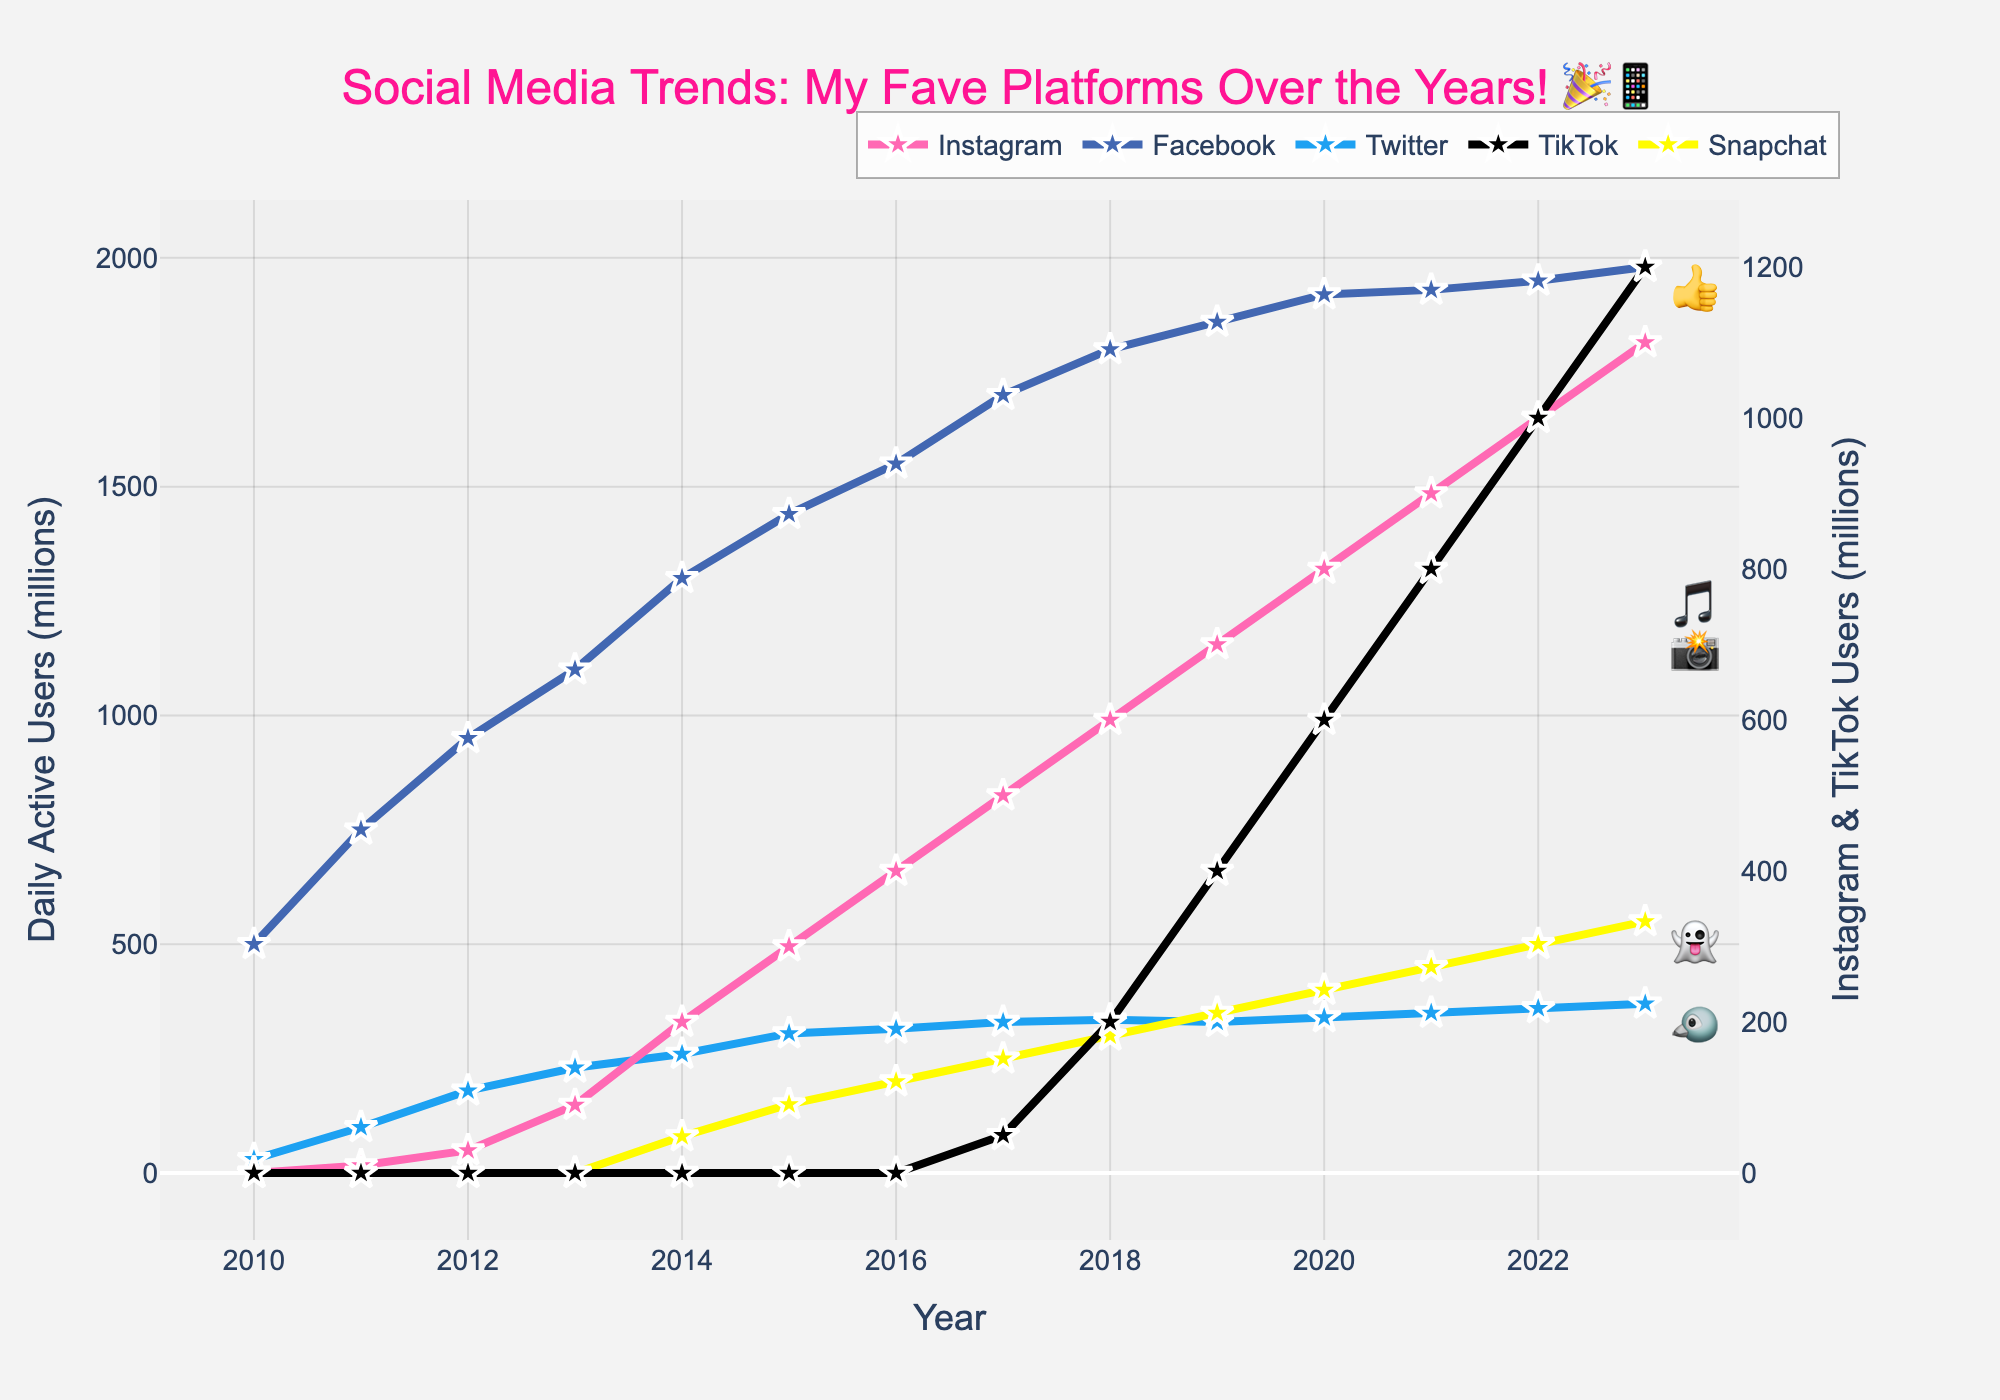What's the trend of daily active users (DAUs) on Facebook from 2010 to 2023? Looking at the line for Facebook, it starts at 500 million DAUs in 2010 and consistently rises each year, reaching 1980 million DAUs by 2023.
Answer: Steadily increasing Which platform had the highest number of DAUs in 2023? By observing the endpoints of each line in 2023, Facebook is at the highest level with 1980 million DAUs.
Answer: Facebook In which year did Instagram surpass 500 million DAUs? By identifying the point where Instagram's line crosses the 500 million DAUs mark, it happens in the year 2017.
Answer: 2017 Compare the growth of TikTok and Twitter from 2018 to 2023. Which one grew more? TikTok grew from 200 million to 1200 million (an increase of 1000 million), while Twitter grew from 335 million to 370 million (an increase of 35 million).
Answer: TikTok grew more What year did TikTok hit 800 million DAUs? By locating the data point on TikTok's line at 800 million DAUs, it occurs in 2021.
Answer: 2021 Which platform had the second-highest growth rate between 2010 and 2023? First, calculate the growth for each platform. Instagram (0 to 1100 million), Facebook (500 to 1980 million), Twitter (30 to 370 million), TikTok (0 to 1200 million), and Snapchat (0 to 550 million). Although TikTok had the highest growth, Instagram has the second-highest growth (by 1100 million).
Answer: Instagram What is the total number of DAUs for all platforms combined in 2020? Sum the number of DAUs for each platform in 2020: Instagram (800) + Facebook (1920) + Twitter (340) + TikTok (600) + Snapchat (400). Total: 800 + 1920 + 340 + 600 + 400 = 4060 million DAUs.
Answer: 4060 million Which platforms have a noticeable drop or plateau in their DAU trends between 2010 and 2023? Observe the line chart for any platforms with a drop or plateau. Twitter shows a slight decline around 2019-2020 and Snapchat has a plateau period before 2016.
Answer: Twitter, Snapchat How does Instagram's growth from 2010 to 2015 compare to its growth from 2016 to 2021? From 2010 to 2015, Instagram grew from 0 to 300 million DAUs (increase of 300 million). From 2016 to 2021, it grew from 400 to 900 million DAUs (an increase of 500 million).
Answer: Greater growth from 2016 to 2021 Which year did Snapchat reach 450 million DAUs? Locate the point on Snapchat's line where it touches 450 million DAUs, which is in 2021.
Answer: 2021 